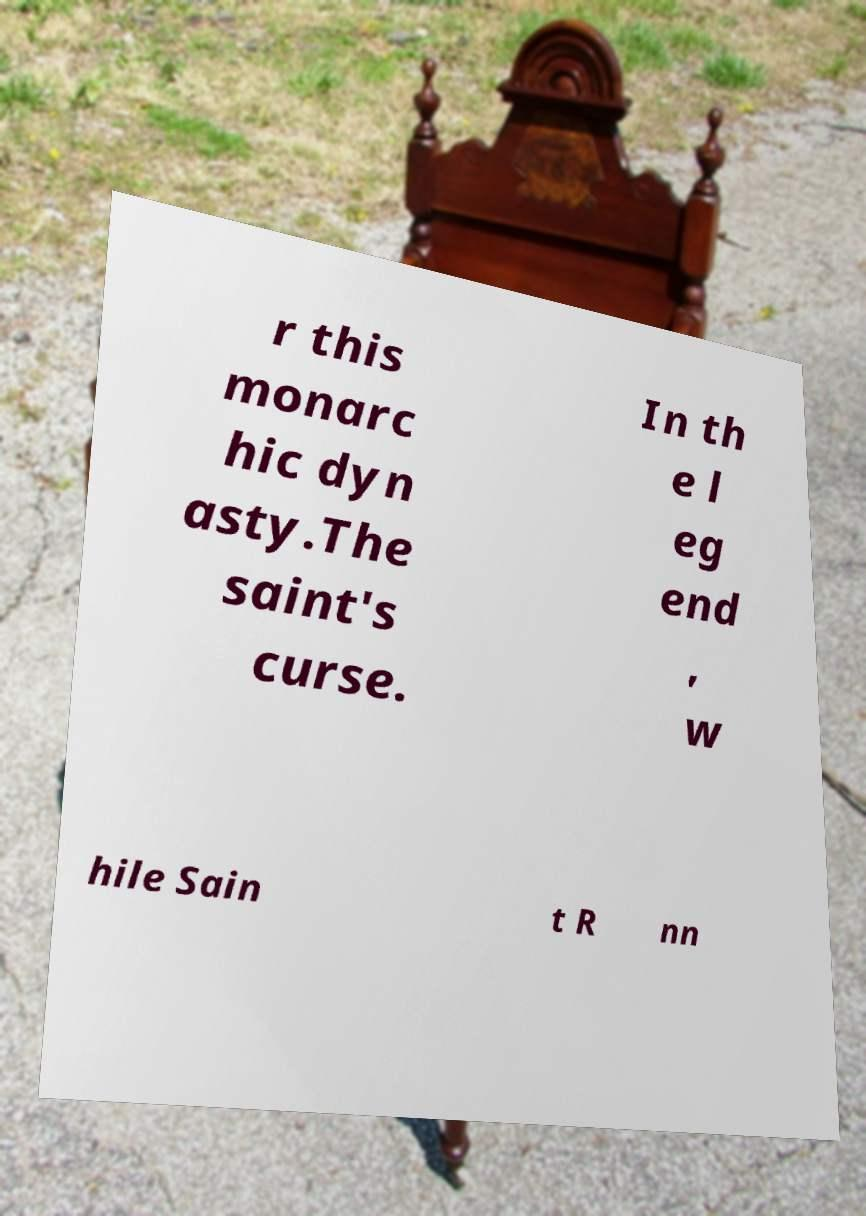What messages or text are displayed in this image? I need them in a readable, typed format. r this monarc hic dyn asty.The saint's curse. In th e l eg end , w hile Sain t R nn 